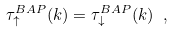Convert formula to latex. <formula><loc_0><loc_0><loc_500><loc_500>\tau ^ { B A P } _ { \uparrow } ( k ) = \tau ^ { B A P } _ { \downarrow } ( k ) \ ,</formula> 